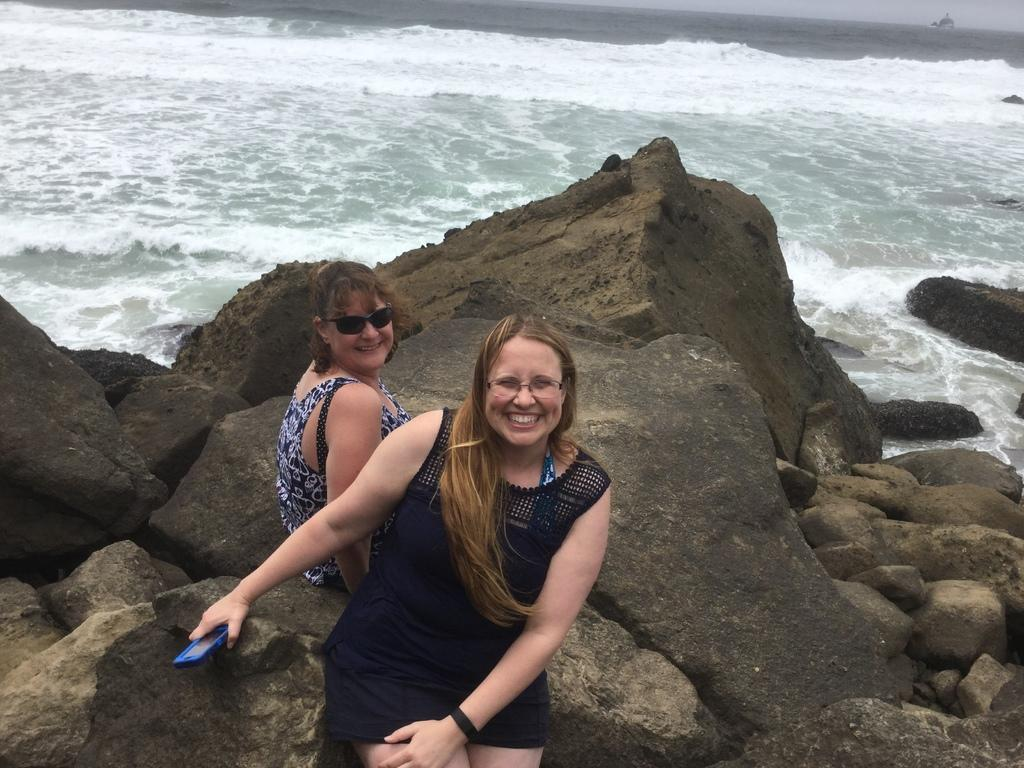How many people are in the image? There are two women in the image. What is the facial expression of the women? The women are smiling. Where are the women sitting in the image? The women are sitting on a surface. What type of natural elements can be seen in the image? There are rocks and water visible in the image. What book is the woman holding in her ear in the image? There is no book or woman holding a book in her ear in the image. 